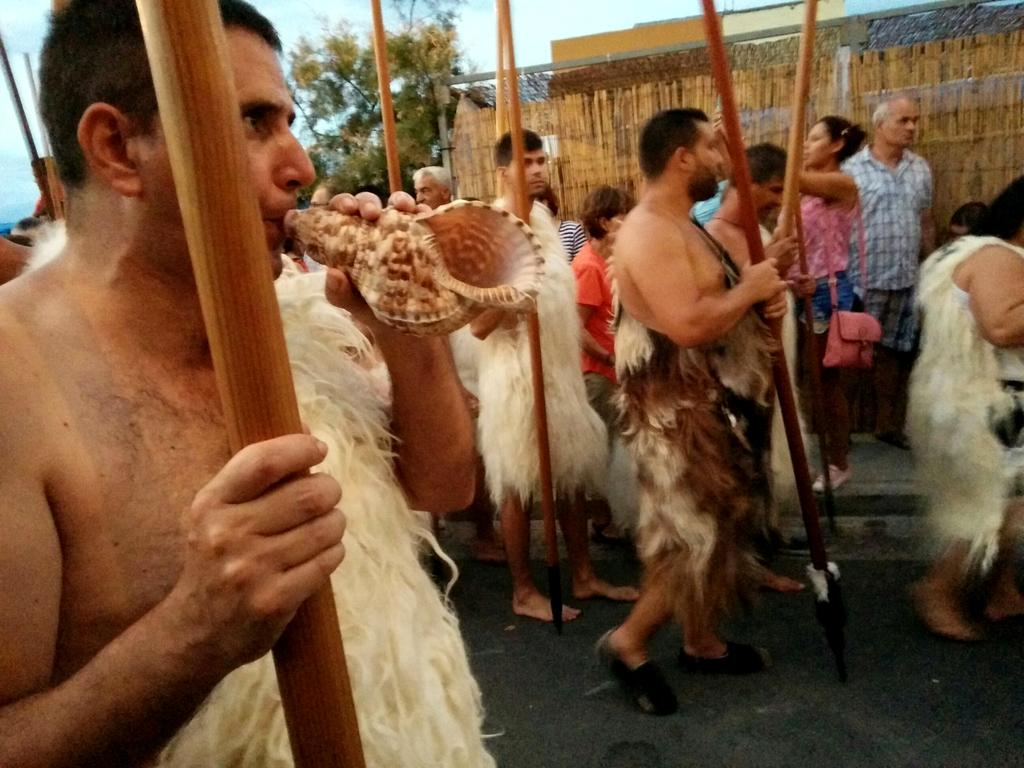What are the people in the image holding? The people in the image are holding sticks. Can you describe the people in the background of the image? There are people standing in the background of the image. What can be seen in the background of the image besides the people? There is a wall, a tree, and the sky visible in the background of the image. What type of noise can be heard coming from the jellyfish in the image? There are no jellyfish present in the image, so it's not possible to determine what, if any, noise might be heard. 